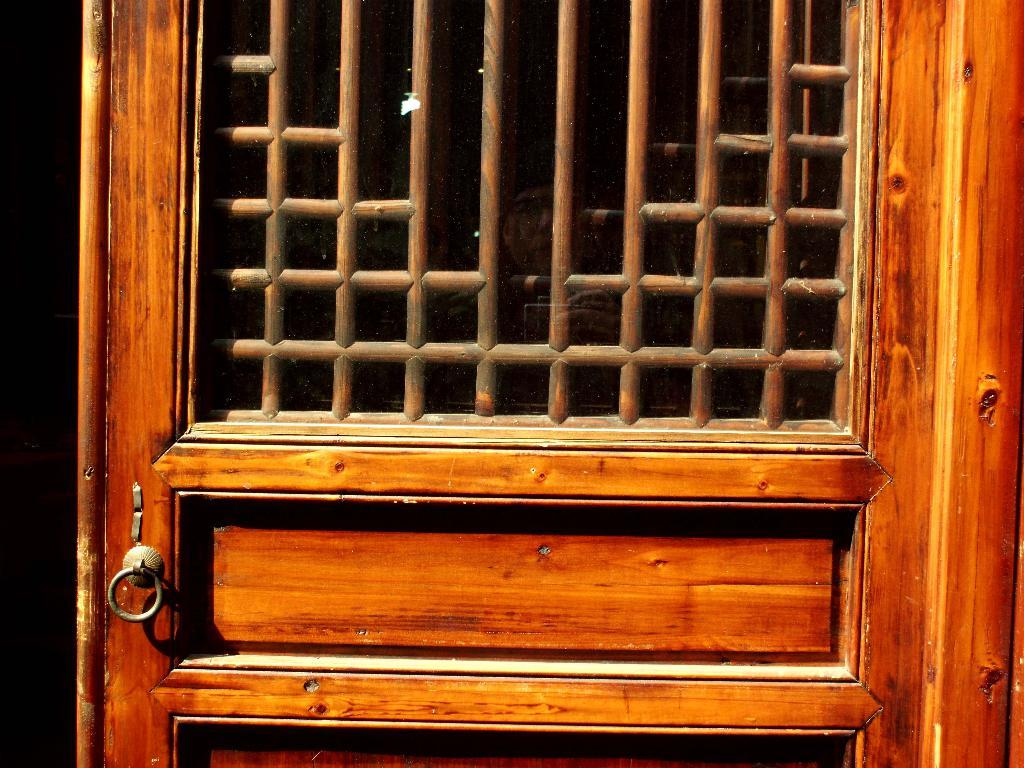What type of door is visible in the image? There is a wooden door in the image. What is located in the middle of the door? There is a fence in the middle of the door. What type of war is depicted in the image? There is no mention of a war or any conflict in the image. The image only describes a wooden door with a fence in the middle. 